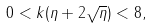<formula> <loc_0><loc_0><loc_500><loc_500>0 < k ( \eta + 2 \sqrt { \eta } ) < 8 ,</formula> 